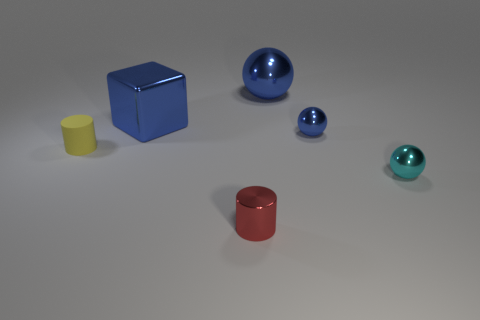How would you describe the colors in the image? The image displays a muted and somewhat desaturated color palette comprising mainly of primary colors. You can see a blue cube, a yellow shorter cylinder, and a red taller cylinder. There are also different shades of blue on the spheres, creating a simple yet visually engaging composition. 